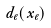Convert formula to latex. <formula><loc_0><loc_0><loc_500><loc_500>d _ { e } ( x _ { e } )</formula> 